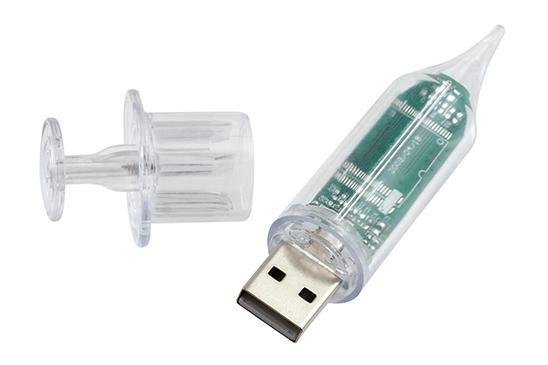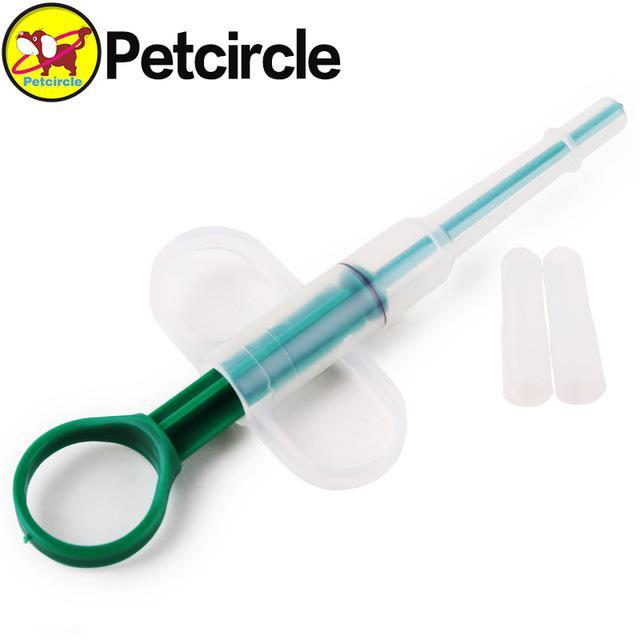The first image is the image on the left, the second image is the image on the right. Examine the images to the left and right. Is the description "There are three objects with plungers in the image on the right." accurate? Answer yes or no. No. 